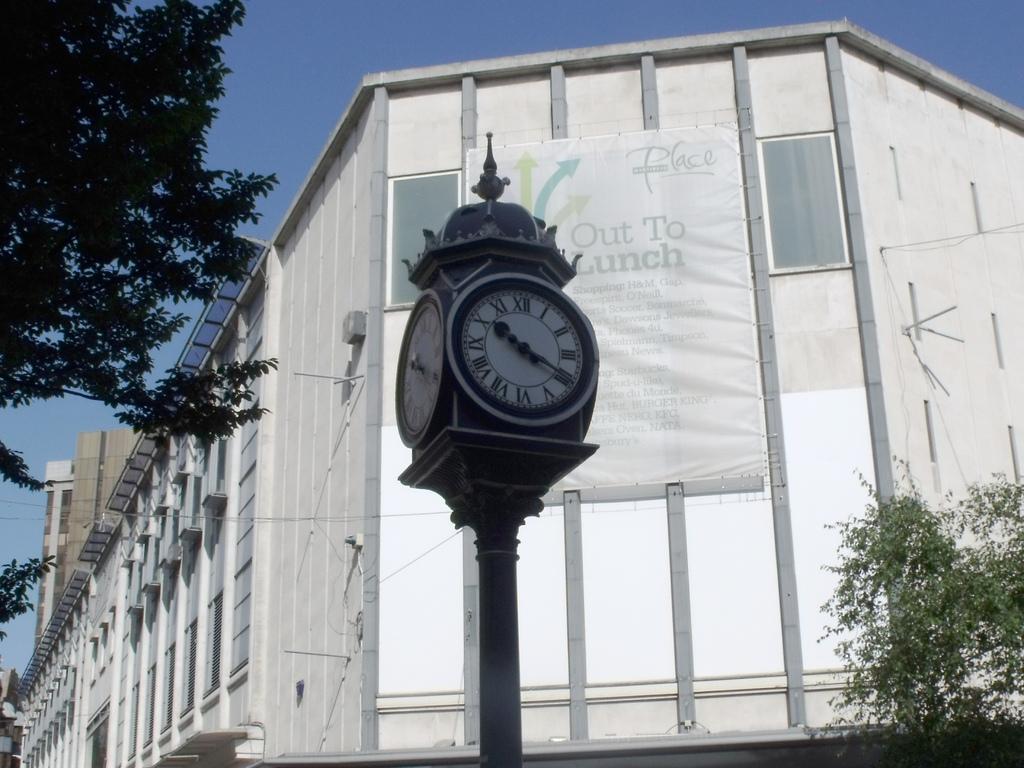Which roman numeral is the short hand of the clock on?
Keep it short and to the point. X. 